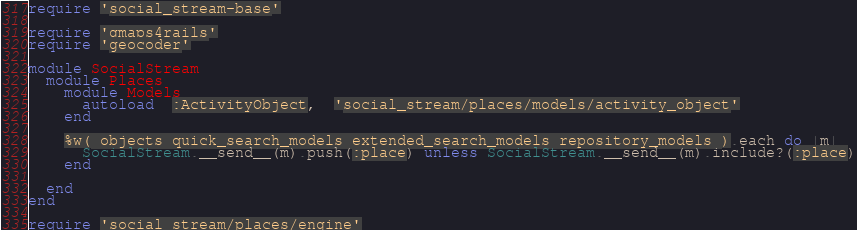<code> <loc_0><loc_0><loc_500><loc_500><_Ruby_>require 'social_stream-base'

require 'gmaps4rails'
require 'geocoder'

module SocialStream
  module Places
    module Models
      autoload  :ActivityObject,  'social_stream/places/models/activity_object'
    end
    
    %w( objects quick_search_models extended_search_models repository_models ).each do |m|
      SocialStream.__send__(m).push(:place) unless SocialStream.__send__(m).include?(:place)
    end

  end
end

require 'social_stream/places/engine'
</code> 